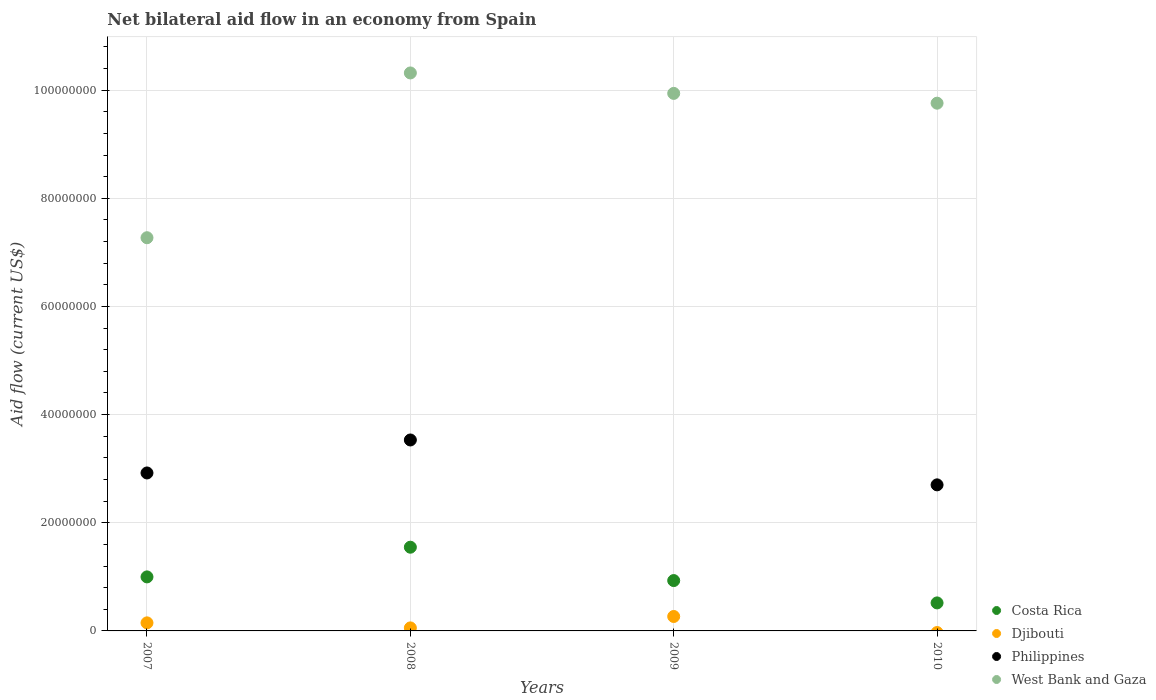Is the number of dotlines equal to the number of legend labels?
Your response must be concise. No. What is the net bilateral aid flow in Djibouti in 2007?
Keep it short and to the point. 1.49e+06. Across all years, what is the maximum net bilateral aid flow in West Bank and Gaza?
Your answer should be very brief. 1.03e+08. Across all years, what is the minimum net bilateral aid flow in Costa Rica?
Provide a short and direct response. 5.18e+06. What is the total net bilateral aid flow in Djibouti in the graph?
Your response must be concise. 4.72e+06. What is the difference between the net bilateral aid flow in Philippines in 2007 and that in 2008?
Your response must be concise. -6.10e+06. What is the difference between the net bilateral aid flow in Djibouti in 2007 and the net bilateral aid flow in West Bank and Gaza in 2008?
Ensure brevity in your answer.  -1.02e+08. What is the average net bilateral aid flow in West Bank and Gaza per year?
Keep it short and to the point. 9.32e+07. In the year 2009, what is the difference between the net bilateral aid flow in Djibouti and net bilateral aid flow in Costa Rica?
Your answer should be compact. -6.64e+06. What is the ratio of the net bilateral aid flow in West Bank and Gaza in 2009 to that in 2010?
Ensure brevity in your answer.  1.02. Is the net bilateral aid flow in West Bank and Gaza in 2007 less than that in 2008?
Your answer should be compact. Yes. What is the difference between the highest and the second highest net bilateral aid flow in West Bank and Gaza?
Your answer should be compact. 3.78e+06. What is the difference between the highest and the lowest net bilateral aid flow in Djibouti?
Offer a very short reply. 2.67e+06. Is the sum of the net bilateral aid flow in West Bank and Gaza in 2007 and 2008 greater than the maximum net bilateral aid flow in Philippines across all years?
Your response must be concise. Yes. Does the net bilateral aid flow in Djibouti monotonically increase over the years?
Provide a short and direct response. No. Is the net bilateral aid flow in Djibouti strictly greater than the net bilateral aid flow in Philippines over the years?
Offer a terse response. No. Is the net bilateral aid flow in West Bank and Gaza strictly less than the net bilateral aid flow in Costa Rica over the years?
Your answer should be very brief. No. How many years are there in the graph?
Offer a terse response. 4. What is the difference between two consecutive major ticks on the Y-axis?
Make the answer very short. 2.00e+07. Are the values on the major ticks of Y-axis written in scientific E-notation?
Offer a terse response. No. Where does the legend appear in the graph?
Offer a terse response. Bottom right. How many legend labels are there?
Your answer should be very brief. 4. How are the legend labels stacked?
Offer a terse response. Vertical. What is the title of the graph?
Your response must be concise. Net bilateral aid flow in an economy from Spain. Does "Armenia" appear as one of the legend labels in the graph?
Provide a short and direct response. No. What is the Aid flow (current US$) of Costa Rica in 2007?
Your response must be concise. 9.99e+06. What is the Aid flow (current US$) of Djibouti in 2007?
Your response must be concise. 1.49e+06. What is the Aid flow (current US$) in Philippines in 2007?
Ensure brevity in your answer.  2.92e+07. What is the Aid flow (current US$) in West Bank and Gaza in 2007?
Offer a very short reply. 7.27e+07. What is the Aid flow (current US$) of Costa Rica in 2008?
Your answer should be very brief. 1.55e+07. What is the Aid flow (current US$) of Djibouti in 2008?
Your response must be concise. 5.60e+05. What is the Aid flow (current US$) of Philippines in 2008?
Your answer should be very brief. 3.53e+07. What is the Aid flow (current US$) in West Bank and Gaza in 2008?
Provide a short and direct response. 1.03e+08. What is the Aid flow (current US$) of Costa Rica in 2009?
Offer a terse response. 9.31e+06. What is the Aid flow (current US$) in Djibouti in 2009?
Your response must be concise. 2.67e+06. What is the Aid flow (current US$) in West Bank and Gaza in 2009?
Offer a terse response. 9.94e+07. What is the Aid flow (current US$) in Costa Rica in 2010?
Give a very brief answer. 5.18e+06. What is the Aid flow (current US$) of Djibouti in 2010?
Provide a succinct answer. 0. What is the Aid flow (current US$) in Philippines in 2010?
Provide a short and direct response. 2.70e+07. What is the Aid flow (current US$) in West Bank and Gaza in 2010?
Ensure brevity in your answer.  9.76e+07. Across all years, what is the maximum Aid flow (current US$) of Costa Rica?
Your answer should be very brief. 1.55e+07. Across all years, what is the maximum Aid flow (current US$) of Djibouti?
Provide a succinct answer. 2.67e+06. Across all years, what is the maximum Aid flow (current US$) in Philippines?
Offer a very short reply. 3.53e+07. Across all years, what is the maximum Aid flow (current US$) of West Bank and Gaza?
Ensure brevity in your answer.  1.03e+08. Across all years, what is the minimum Aid flow (current US$) in Costa Rica?
Your answer should be very brief. 5.18e+06. Across all years, what is the minimum Aid flow (current US$) in West Bank and Gaza?
Provide a succinct answer. 7.27e+07. What is the total Aid flow (current US$) in Costa Rica in the graph?
Offer a terse response. 4.00e+07. What is the total Aid flow (current US$) of Djibouti in the graph?
Your answer should be very brief. 4.72e+06. What is the total Aid flow (current US$) in Philippines in the graph?
Offer a very short reply. 9.15e+07. What is the total Aid flow (current US$) in West Bank and Gaza in the graph?
Your answer should be very brief. 3.73e+08. What is the difference between the Aid flow (current US$) in Costa Rica in 2007 and that in 2008?
Offer a very short reply. -5.49e+06. What is the difference between the Aid flow (current US$) of Djibouti in 2007 and that in 2008?
Offer a very short reply. 9.30e+05. What is the difference between the Aid flow (current US$) of Philippines in 2007 and that in 2008?
Your response must be concise. -6.10e+06. What is the difference between the Aid flow (current US$) of West Bank and Gaza in 2007 and that in 2008?
Make the answer very short. -3.05e+07. What is the difference between the Aid flow (current US$) in Costa Rica in 2007 and that in 2009?
Your answer should be very brief. 6.80e+05. What is the difference between the Aid flow (current US$) of Djibouti in 2007 and that in 2009?
Make the answer very short. -1.18e+06. What is the difference between the Aid flow (current US$) in West Bank and Gaza in 2007 and that in 2009?
Keep it short and to the point. -2.67e+07. What is the difference between the Aid flow (current US$) of Costa Rica in 2007 and that in 2010?
Keep it short and to the point. 4.81e+06. What is the difference between the Aid flow (current US$) of Philippines in 2007 and that in 2010?
Your response must be concise. 2.20e+06. What is the difference between the Aid flow (current US$) in West Bank and Gaza in 2007 and that in 2010?
Make the answer very short. -2.49e+07. What is the difference between the Aid flow (current US$) in Costa Rica in 2008 and that in 2009?
Provide a succinct answer. 6.17e+06. What is the difference between the Aid flow (current US$) of Djibouti in 2008 and that in 2009?
Provide a succinct answer. -2.11e+06. What is the difference between the Aid flow (current US$) in West Bank and Gaza in 2008 and that in 2009?
Offer a terse response. 3.78e+06. What is the difference between the Aid flow (current US$) in Costa Rica in 2008 and that in 2010?
Your response must be concise. 1.03e+07. What is the difference between the Aid flow (current US$) of Philippines in 2008 and that in 2010?
Keep it short and to the point. 8.30e+06. What is the difference between the Aid flow (current US$) of West Bank and Gaza in 2008 and that in 2010?
Provide a succinct answer. 5.59e+06. What is the difference between the Aid flow (current US$) of Costa Rica in 2009 and that in 2010?
Make the answer very short. 4.13e+06. What is the difference between the Aid flow (current US$) of West Bank and Gaza in 2009 and that in 2010?
Your answer should be compact. 1.81e+06. What is the difference between the Aid flow (current US$) in Costa Rica in 2007 and the Aid flow (current US$) in Djibouti in 2008?
Offer a terse response. 9.43e+06. What is the difference between the Aid flow (current US$) of Costa Rica in 2007 and the Aid flow (current US$) of Philippines in 2008?
Keep it short and to the point. -2.53e+07. What is the difference between the Aid flow (current US$) of Costa Rica in 2007 and the Aid flow (current US$) of West Bank and Gaza in 2008?
Offer a very short reply. -9.32e+07. What is the difference between the Aid flow (current US$) in Djibouti in 2007 and the Aid flow (current US$) in Philippines in 2008?
Make the answer very short. -3.38e+07. What is the difference between the Aid flow (current US$) of Djibouti in 2007 and the Aid flow (current US$) of West Bank and Gaza in 2008?
Offer a very short reply. -1.02e+08. What is the difference between the Aid flow (current US$) in Philippines in 2007 and the Aid flow (current US$) in West Bank and Gaza in 2008?
Keep it short and to the point. -7.40e+07. What is the difference between the Aid flow (current US$) of Costa Rica in 2007 and the Aid flow (current US$) of Djibouti in 2009?
Your answer should be very brief. 7.32e+06. What is the difference between the Aid flow (current US$) in Costa Rica in 2007 and the Aid flow (current US$) in West Bank and Gaza in 2009?
Your answer should be compact. -8.94e+07. What is the difference between the Aid flow (current US$) in Djibouti in 2007 and the Aid flow (current US$) in West Bank and Gaza in 2009?
Your answer should be very brief. -9.79e+07. What is the difference between the Aid flow (current US$) of Philippines in 2007 and the Aid flow (current US$) of West Bank and Gaza in 2009?
Provide a succinct answer. -7.02e+07. What is the difference between the Aid flow (current US$) of Costa Rica in 2007 and the Aid flow (current US$) of Philippines in 2010?
Provide a short and direct response. -1.70e+07. What is the difference between the Aid flow (current US$) in Costa Rica in 2007 and the Aid flow (current US$) in West Bank and Gaza in 2010?
Your answer should be compact. -8.76e+07. What is the difference between the Aid flow (current US$) of Djibouti in 2007 and the Aid flow (current US$) of Philippines in 2010?
Your answer should be very brief. -2.55e+07. What is the difference between the Aid flow (current US$) in Djibouti in 2007 and the Aid flow (current US$) in West Bank and Gaza in 2010?
Ensure brevity in your answer.  -9.61e+07. What is the difference between the Aid flow (current US$) of Philippines in 2007 and the Aid flow (current US$) of West Bank and Gaza in 2010?
Offer a very short reply. -6.84e+07. What is the difference between the Aid flow (current US$) of Costa Rica in 2008 and the Aid flow (current US$) of Djibouti in 2009?
Your answer should be compact. 1.28e+07. What is the difference between the Aid flow (current US$) of Costa Rica in 2008 and the Aid flow (current US$) of West Bank and Gaza in 2009?
Your answer should be compact. -8.39e+07. What is the difference between the Aid flow (current US$) of Djibouti in 2008 and the Aid flow (current US$) of West Bank and Gaza in 2009?
Your answer should be compact. -9.88e+07. What is the difference between the Aid flow (current US$) of Philippines in 2008 and the Aid flow (current US$) of West Bank and Gaza in 2009?
Your answer should be very brief. -6.41e+07. What is the difference between the Aid flow (current US$) in Costa Rica in 2008 and the Aid flow (current US$) in Philippines in 2010?
Your answer should be compact. -1.15e+07. What is the difference between the Aid flow (current US$) of Costa Rica in 2008 and the Aid flow (current US$) of West Bank and Gaza in 2010?
Keep it short and to the point. -8.21e+07. What is the difference between the Aid flow (current US$) of Djibouti in 2008 and the Aid flow (current US$) of Philippines in 2010?
Give a very brief answer. -2.64e+07. What is the difference between the Aid flow (current US$) in Djibouti in 2008 and the Aid flow (current US$) in West Bank and Gaza in 2010?
Give a very brief answer. -9.70e+07. What is the difference between the Aid flow (current US$) of Philippines in 2008 and the Aid flow (current US$) of West Bank and Gaza in 2010?
Offer a terse response. -6.23e+07. What is the difference between the Aid flow (current US$) of Costa Rica in 2009 and the Aid flow (current US$) of Philippines in 2010?
Offer a very short reply. -1.77e+07. What is the difference between the Aid flow (current US$) of Costa Rica in 2009 and the Aid flow (current US$) of West Bank and Gaza in 2010?
Your answer should be compact. -8.83e+07. What is the difference between the Aid flow (current US$) in Djibouti in 2009 and the Aid flow (current US$) in Philippines in 2010?
Give a very brief answer. -2.43e+07. What is the difference between the Aid flow (current US$) in Djibouti in 2009 and the Aid flow (current US$) in West Bank and Gaza in 2010?
Make the answer very short. -9.49e+07. What is the average Aid flow (current US$) in Costa Rica per year?
Offer a very short reply. 9.99e+06. What is the average Aid flow (current US$) of Djibouti per year?
Provide a short and direct response. 1.18e+06. What is the average Aid flow (current US$) of Philippines per year?
Provide a short and direct response. 2.29e+07. What is the average Aid flow (current US$) of West Bank and Gaza per year?
Your answer should be very brief. 9.32e+07. In the year 2007, what is the difference between the Aid flow (current US$) of Costa Rica and Aid flow (current US$) of Djibouti?
Give a very brief answer. 8.50e+06. In the year 2007, what is the difference between the Aid flow (current US$) in Costa Rica and Aid flow (current US$) in Philippines?
Your response must be concise. -1.92e+07. In the year 2007, what is the difference between the Aid flow (current US$) in Costa Rica and Aid flow (current US$) in West Bank and Gaza?
Ensure brevity in your answer.  -6.27e+07. In the year 2007, what is the difference between the Aid flow (current US$) of Djibouti and Aid flow (current US$) of Philippines?
Keep it short and to the point. -2.77e+07. In the year 2007, what is the difference between the Aid flow (current US$) of Djibouti and Aid flow (current US$) of West Bank and Gaza?
Your response must be concise. -7.12e+07. In the year 2007, what is the difference between the Aid flow (current US$) in Philippines and Aid flow (current US$) in West Bank and Gaza?
Make the answer very short. -4.35e+07. In the year 2008, what is the difference between the Aid flow (current US$) in Costa Rica and Aid flow (current US$) in Djibouti?
Your response must be concise. 1.49e+07. In the year 2008, what is the difference between the Aid flow (current US$) in Costa Rica and Aid flow (current US$) in Philippines?
Keep it short and to the point. -1.98e+07. In the year 2008, what is the difference between the Aid flow (current US$) in Costa Rica and Aid flow (current US$) in West Bank and Gaza?
Offer a terse response. -8.77e+07. In the year 2008, what is the difference between the Aid flow (current US$) of Djibouti and Aid flow (current US$) of Philippines?
Your response must be concise. -3.48e+07. In the year 2008, what is the difference between the Aid flow (current US$) of Djibouti and Aid flow (current US$) of West Bank and Gaza?
Give a very brief answer. -1.03e+08. In the year 2008, what is the difference between the Aid flow (current US$) in Philippines and Aid flow (current US$) in West Bank and Gaza?
Provide a short and direct response. -6.79e+07. In the year 2009, what is the difference between the Aid flow (current US$) of Costa Rica and Aid flow (current US$) of Djibouti?
Ensure brevity in your answer.  6.64e+06. In the year 2009, what is the difference between the Aid flow (current US$) in Costa Rica and Aid flow (current US$) in West Bank and Gaza?
Your answer should be very brief. -9.01e+07. In the year 2009, what is the difference between the Aid flow (current US$) in Djibouti and Aid flow (current US$) in West Bank and Gaza?
Give a very brief answer. -9.67e+07. In the year 2010, what is the difference between the Aid flow (current US$) in Costa Rica and Aid flow (current US$) in Philippines?
Provide a short and direct response. -2.18e+07. In the year 2010, what is the difference between the Aid flow (current US$) of Costa Rica and Aid flow (current US$) of West Bank and Gaza?
Make the answer very short. -9.24e+07. In the year 2010, what is the difference between the Aid flow (current US$) of Philippines and Aid flow (current US$) of West Bank and Gaza?
Provide a short and direct response. -7.06e+07. What is the ratio of the Aid flow (current US$) in Costa Rica in 2007 to that in 2008?
Provide a succinct answer. 0.65. What is the ratio of the Aid flow (current US$) in Djibouti in 2007 to that in 2008?
Ensure brevity in your answer.  2.66. What is the ratio of the Aid flow (current US$) in Philippines in 2007 to that in 2008?
Your answer should be very brief. 0.83. What is the ratio of the Aid flow (current US$) in West Bank and Gaza in 2007 to that in 2008?
Your answer should be very brief. 0.7. What is the ratio of the Aid flow (current US$) of Costa Rica in 2007 to that in 2009?
Offer a terse response. 1.07. What is the ratio of the Aid flow (current US$) in Djibouti in 2007 to that in 2009?
Your answer should be very brief. 0.56. What is the ratio of the Aid flow (current US$) in West Bank and Gaza in 2007 to that in 2009?
Your response must be concise. 0.73. What is the ratio of the Aid flow (current US$) in Costa Rica in 2007 to that in 2010?
Provide a succinct answer. 1.93. What is the ratio of the Aid flow (current US$) in Philippines in 2007 to that in 2010?
Make the answer very short. 1.08. What is the ratio of the Aid flow (current US$) in West Bank and Gaza in 2007 to that in 2010?
Provide a succinct answer. 0.75. What is the ratio of the Aid flow (current US$) in Costa Rica in 2008 to that in 2009?
Give a very brief answer. 1.66. What is the ratio of the Aid flow (current US$) in Djibouti in 2008 to that in 2009?
Offer a very short reply. 0.21. What is the ratio of the Aid flow (current US$) in West Bank and Gaza in 2008 to that in 2009?
Offer a very short reply. 1.04. What is the ratio of the Aid flow (current US$) of Costa Rica in 2008 to that in 2010?
Keep it short and to the point. 2.99. What is the ratio of the Aid flow (current US$) in Philippines in 2008 to that in 2010?
Your answer should be compact. 1.31. What is the ratio of the Aid flow (current US$) in West Bank and Gaza in 2008 to that in 2010?
Your response must be concise. 1.06. What is the ratio of the Aid flow (current US$) of Costa Rica in 2009 to that in 2010?
Your answer should be very brief. 1.8. What is the ratio of the Aid flow (current US$) of West Bank and Gaza in 2009 to that in 2010?
Give a very brief answer. 1.02. What is the difference between the highest and the second highest Aid flow (current US$) of Costa Rica?
Provide a short and direct response. 5.49e+06. What is the difference between the highest and the second highest Aid flow (current US$) in Djibouti?
Offer a very short reply. 1.18e+06. What is the difference between the highest and the second highest Aid flow (current US$) of Philippines?
Ensure brevity in your answer.  6.10e+06. What is the difference between the highest and the second highest Aid flow (current US$) of West Bank and Gaza?
Ensure brevity in your answer.  3.78e+06. What is the difference between the highest and the lowest Aid flow (current US$) of Costa Rica?
Your answer should be very brief. 1.03e+07. What is the difference between the highest and the lowest Aid flow (current US$) of Djibouti?
Give a very brief answer. 2.67e+06. What is the difference between the highest and the lowest Aid flow (current US$) of Philippines?
Provide a short and direct response. 3.53e+07. What is the difference between the highest and the lowest Aid flow (current US$) of West Bank and Gaza?
Keep it short and to the point. 3.05e+07. 